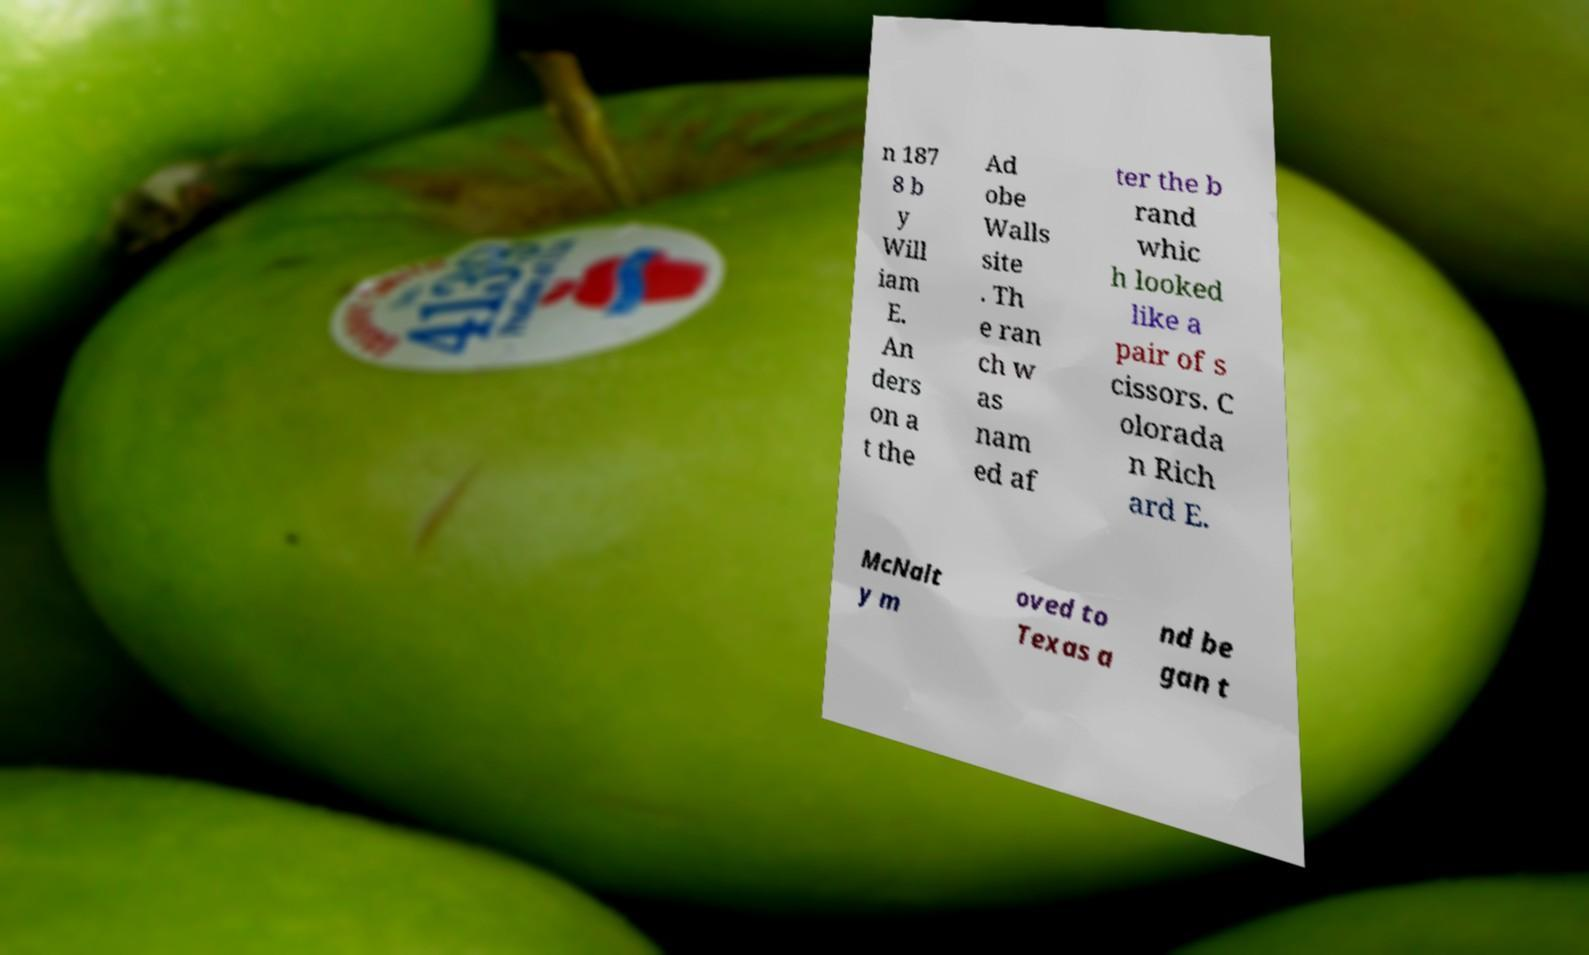Can you accurately transcribe the text from the provided image for me? n 187 8 b y Will iam E. An ders on a t the Ad obe Walls site . Th e ran ch w as nam ed af ter the b rand whic h looked like a pair of s cissors. C olorada n Rich ard E. McNalt y m oved to Texas a nd be gan t 